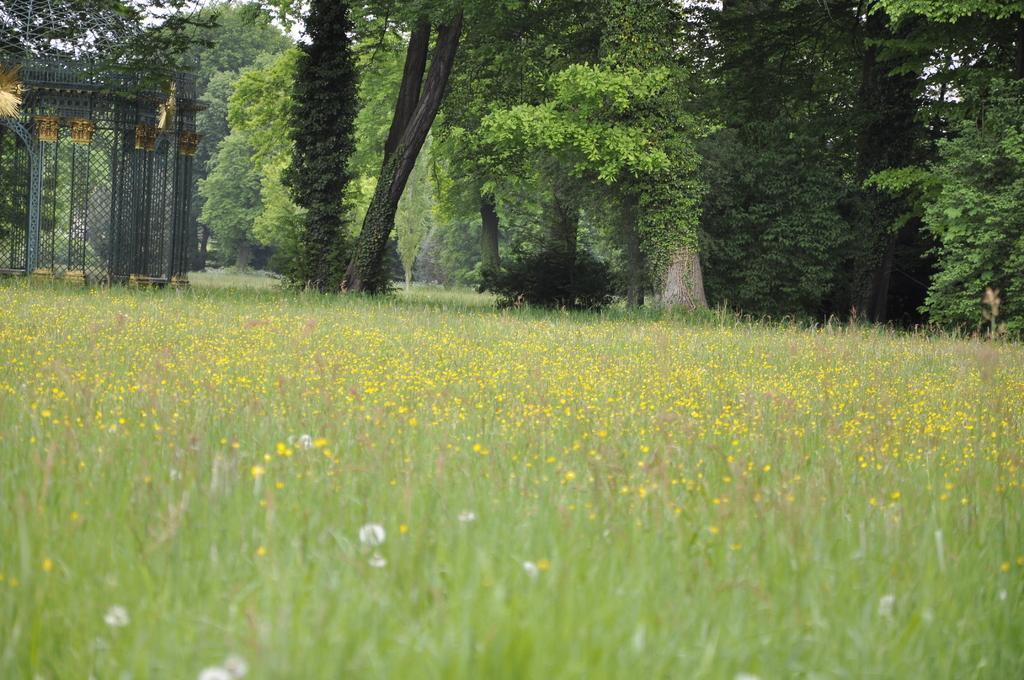Please provide a concise description of this image. In this picture we can see few flowers, grass and trees, and also we can find metal rods. 